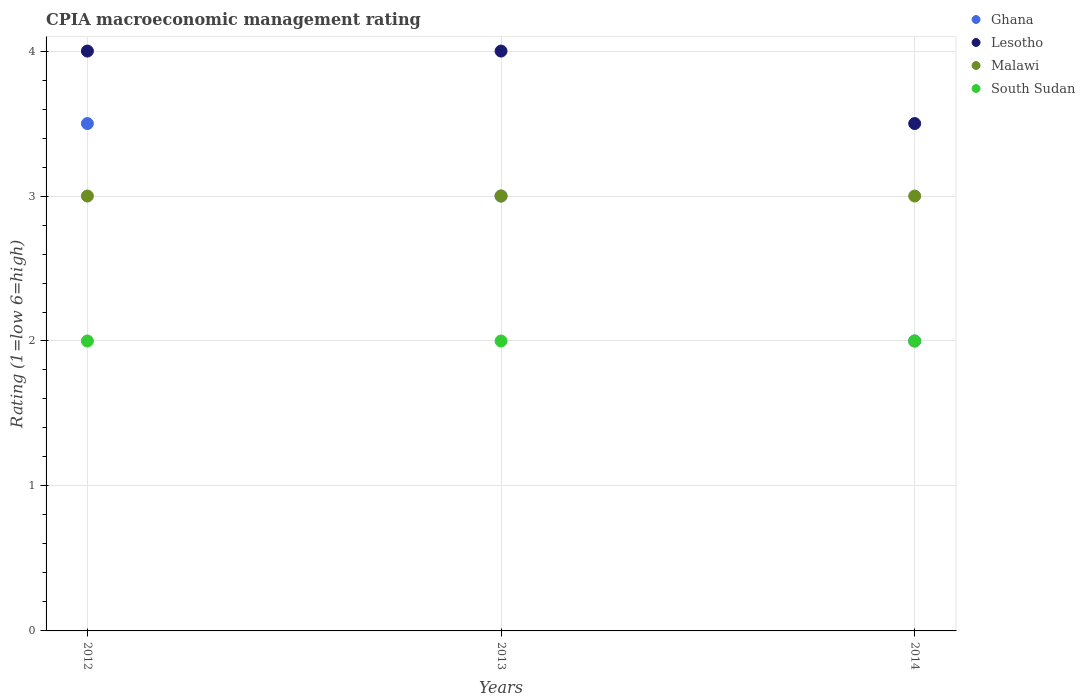Is the number of dotlines equal to the number of legend labels?
Provide a short and direct response. Yes. Across all years, what is the minimum CPIA rating in South Sudan?
Your answer should be very brief. 2. In which year was the CPIA rating in Malawi minimum?
Your answer should be very brief. 2012. What is the total CPIA rating in Malawi in the graph?
Offer a very short reply. 9. What is the difference between the CPIA rating in South Sudan in 2014 and the CPIA rating in Lesotho in 2012?
Offer a very short reply. -2. What is the average CPIA rating in Malawi per year?
Provide a short and direct response. 3. Is the CPIA rating in Malawi in 2012 less than that in 2013?
Ensure brevity in your answer.  No. In how many years, is the CPIA rating in South Sudan greater than the average CPIA rating in South Sudan taken over all years?
Your response must be concise. 0. Is the sum of the CPIA rating in Malawi in 2012 and 2013 greater than the maximum CPIA rating in South Sudan across all years?
Your response must be concise. Yes. Is the CPIA rating in Ghana strictly greater than the CPIA rating in Lesotho over the years?
Provide a short and direct response. No. How many dotlines are there?
Keep it short and to the point. 4. Does the graph contain grids?
Your answer should be compact. Yes. Where does the legend appear in the graph?
Your answer should be very brief. Top right. What is the title of the graph?
Offer a very short reply. CPIA macroeconomic management rating. Does "Guyana" appear as one of the legend labels in the graph?
Offer a terse response. No. What is the label or title of the Y-axis?
Your answer should be very brief. Rating (1=low 6=high). What is the Rating (1=low 6=high) of Ghana in 2012?
Provide a succinct answer. 3.5. What is the Rating (1=low 6=high) of Lesotho in 2013?
Your answer should be very brief. 4. What is the Rating (1=low 6=high) in South Sudan in 2013?
Make the answer very short. 2. What is the Rating (1=low 6=high) in Ghana in 2014?
Provide a short and direct response. 2. What is the Rating (1=low 6=high) of Malawi in 2014?
Your answer should be very brief. 3. Across all years, what is the maximum Rating (1=low 6=high) of Malawi?
Make the answer very short. 3. Across all years, what is the minimum Rating (1=low 6=high) of Lesotho?
Provide a short and direct response. 3.5. Across all years, what is the minimum Rating (1=low 6=high) in Malawi?
Your answer should be very brief. 3. Across all years, what is the minimum Rating (1=low 6=high) in South Sudan?
Your response must be concise. 2. What is the total Rating (1=low 6=high) of Ghana in the graph?
Your answer should be compact. 8.5. What is the total Rating (1=low 6=high) in South Sudan in the graph?
Make the answer very short. 6. What is the difference between the Rating (1=low 6=high) of Ghana in 2012 and that in 2013?
Ensure brevity in your answer.  0.5. What is the difference between the Rating (1=low 6=high) in Lesotho in 2012 and that in 2013?
Your answer should be compact. 0. What is the difference between the Rating (1=low 6=high) of Ghana in 2012 and that in 2014?
Your answer should be very brief. 1.5. What is the difference between the Rating (1=low 6=high) of Ghana in 2013 and that in 2014?
Provide a succinct answer. 1. What is the difference between the Rating (1=low 6=high) in Lesotho in 2013 and that in 2014?
Ensure brevity in your answer.  0.5. What is the difference between the Rating (1=low 6=high) in Ghana in 2012 and the Rating (1=low 6=high) in South Sudan in 2013?
Your response must be concise. 1.5. What is the difference between the Rating (1=low 6=high) of Lesotho in 2012 and the Rating (1=low 6=high) of Malawi in 2013?
Provide a short and direct response. 1. What is the difference between the Rating (1=low 6=high) of Lesotho in 2012 and the Rating (1=low 6=high) of South Sudan in 2013?
Offer a very short reply. 2. What is the difference between the Rating (1=low 6=high) of Malawi in 2012 and the Rating (1=low 6=high) of South Sudan in 2013?
Keep it short and to the point. 1. What is the difference between the Rating (1=low 6=high) in Ghana in 2012 and the Rating (1=low 6=high) in South Sudan in 2014?
Offer a terse response. 1.5. What is the difference between the Rating (1=low 6=high) in Lesotho in 2012 and the Rating (1=low 6=high) in Malawi in 2014?
Provide a succinct answer. 1. What is the difference between the Rating (1=low 6=high) in Lesotho in 2012 and the Rating (1=low 6=high) in South Sudan in 2014?
Provide a short and direct response. 2. What is the difference between the Rating (1=low 6=high) of Ghana in 2013 and the Rating (1=low 6=high) of Lesotho in 2014?
Your response must be concise. -0.5. What is the difference between the Rating (1=low 6=high) of Ghana in 2013 and the Rating (1=low 6=high) of South Sudan in 2014?
Give a very brief answer. 1. What is the difference between the Rating (1=low 6=high) of Lesotho in 2013 and the Rating (1=low 6=high) of Malawi in 2014?
Your answer should be compact. 1. What is the average Rating (1=low 6=high) in Ghana per year?
Provide a succinct answer. 2.83. What is the average Rating (1=low 6=high) of Lesotho per year?
Your response must be concise. 3.83. What is the average Rating (1=low 6=high) of Malawi per year?
Provide a succinct answer. 3. In the year 2012, what is the difference between the Rating (1=low 6=high) in Lesotho and Rating (1=low 6=high) in Malawi?
Your response must be concise. 1. In the year 2012, what is the difference between the Rating (1=low 6=high) in Lesotho and Rating (1=low 6=high) in South Sudan?
Your response must be concise. 2. In the year 2013, what is the difference between the Rating (1=low 6=high) of Ghana and Rating (1=low 6=high) of Lesotho?
Your response must be concise. -1. In the year 2013, what is the difference between the Rating (1=low 6=high) of Ghana and Rating (1=low 6=high) of Malawi?
Ensure brevity in your answer.  0. In the year 2013, what is the difference between the Rating (1=low 6=high) of Lesotho and Rating (1=low 6=high) of South Sudan?
Give a very brief answer. 2. In the year 2014, what is the difference between the Rating (1=low 6=high) of Ghana and Rating (1=low 6=high) of Lesotho?
Offer a very short reply. -1.5. In the year 2014, what is the difference between the Rating (1=low 6=high) of Ghana and Rating (1=low 6=high) of Malawi?
Make the answer very short. -1. In the year 2014, what is the difference between the Rating (1=low 6=high) in Malawi and Rating (1=low 6=high) in South Sudan?
Keep it short and to the point. 1. What is the ratio of the Rating (1=low 6=high) in Lesotho in 2012 to that in 2013?
Your response must be concise. 1. What is the ratio of the Rating (1=low 6=high) in Malawi in 2012 to that in 2013?
Provide a succinct answer. 1. What is the ratio of the Rating (1=low 6=high) in South Sudan in 2012 to that in 2014?
Provide a short and direct response. 1. What is the ratio of the Rating (1=low 6=high) of Malawi in 2013 to that in 2014?
Provide a succinct answer. 1. What is the ratio of the Rating (1=low 6=high) in South Sudan in 2013 to that in 2014?
Your answer should be compact. 1. What is the difference between the highest and the second highest Rating (1=low 6=high) in South Sudan?
Your answer should be compact. 0. What is the difference between the highest and the lowest Rating (1=low 6=high) of Lesotho?
Offer a very short reply. 0.5. What is the difference between the highest and the lowest Rating (1=low 6=high) of Malawi?
Make the answer very short. 0. 